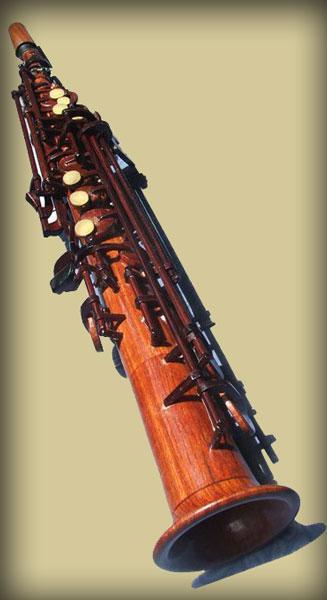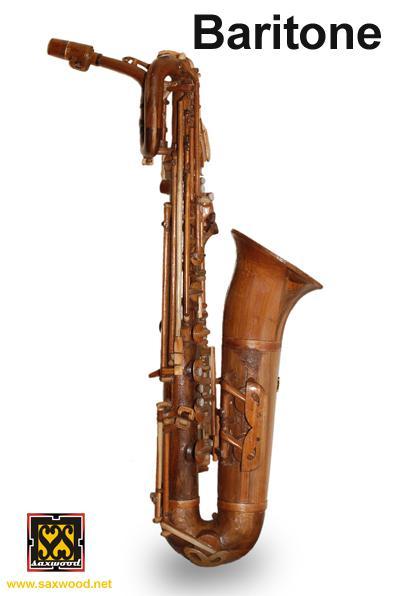The first image is the image on the left, the second image is the image on the right. Assess this claim about the two images: "There are at least three saxophones.". Correct or not? Answer yes or no. No. The first image is the image on the left, the second image is the image on the right. For the images displayed, is the sentence "An image shows at least two wooden instruments displayed side-by-side." factually correct? Answer yes or no. No. 